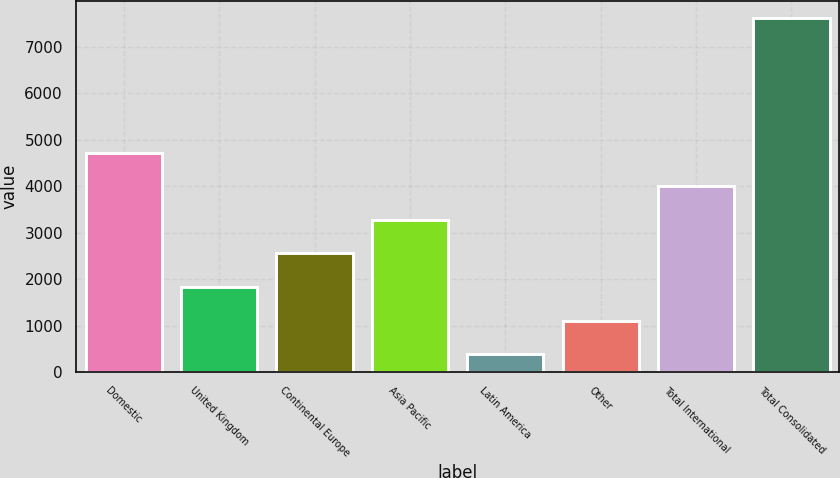Convert chart to OTSL. <chart><loc_0><loc_0><loc_500><loc_500><bar_chart><fcel>Domestic<fcel>United Kingdom<fcel>Continental Europe<fcel>Asia Pacific<fcel>Latin America<fcel>Other<fcel>Total International<fcel>Total Consolidated<nl><fcel>4721.68<fcel>1829.56<fcel>2552.59<fcel>3275.62<fcel>383.5<fcel>1106.53<fcel>3998.65<fcel>7613.8<nl></chart> 